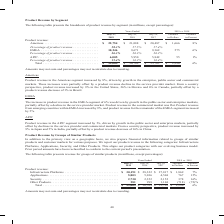From Cisco Systems's financial document, Which years does the table provide information for the breakdown of the company's product revenue by segment? The document contains multiple relevant values: 2019, 2018, 2017. From the document: "019 vs. 2018 July 27, 2019 July 28, 2018 July 29, 2017 Variance in Dollars Variance in Percent Product revenue: Americas . $ 22,754 $ 21,088 $ 20,487 ..." Also, What was the product revenue from Americas in 2017? According to the financial document, 20,487 (in millions). The relevant text states: "t Product revenue: Americas . $ 22,754 $ 21,088 $ 20,487 $ 1,666 8% Percentage of product revenue . 58.3% 57.5% 57.4% EMEA . 10,246 9,671 9,369 575 6% Perce..." Also, What was the variance in dollars for the product revenue from EMEA for 2019 and 2018? According to the financial document, 575 (in millions). The relevant text states: "nue . 58.3% 57.5% 57.4% EMEA . 10,246 9,671 9,369 575 6% Percentage of product revenue . 26.3% 26.3% 26.2% APJC. . 6,005 5,950 5,849 55 1% Percentage of..." Also, can you calculate: What was the change in the product revenue from APJC between 2017 and 2018? Based on the calculation: 5,950-5,849, the result is 101 (in millions). This is based on the information: "t revenue . 26.3% 26.3% 26.2% APJC. . 6,005 5,950 5,849 55 1% Percentage of product revenue . 15.4% 16.2% 16.4% Total . $ 39,005 $ 36,709 $ 35,705 $ 2,296 product revenue . 26.3% 26.3% 26.2% APJC. . 6..." The key data points involved are: 5,849, 5,950. Also, can you calculate: What was the change in the product revenue from Americas between 2017 and 2018? Based on the calculation: 21,088-20,487, the result is 601 (in millions). This is based on the information: "t Product revenue: Americas . $ 22,754 $ 21,088 $ 20,487 $ 1,666 8% Percentage of product revenue . 58.3% 57.5% 57.4% EMEA . 10,246 9,671 9,369 575 6% Perce in Percent Product revenue: Americas . $ 22..." The key data points involved are: 20,487, 21,088. Also, can you calculate: What was the percentage change in the total revenue from all segments between 2017 and 2018? To answer this question, I need to perform calculations using the financial data. The calculation is: (36,709-35,705)/35,705, which equals 2.81 (percentage). This is based on the information: "ct revenue . 15.4% 16.2% 16.4% Total . $ 39,005 $ 36,709 $ 35,705 $ 2,296 6% e . 15.4% 16.2% 16.4% Total . $ 39,005 $ 36,709 $ 35,705 $ 2,296 6%..." The key data points involved are: 35,705, 36,709. 